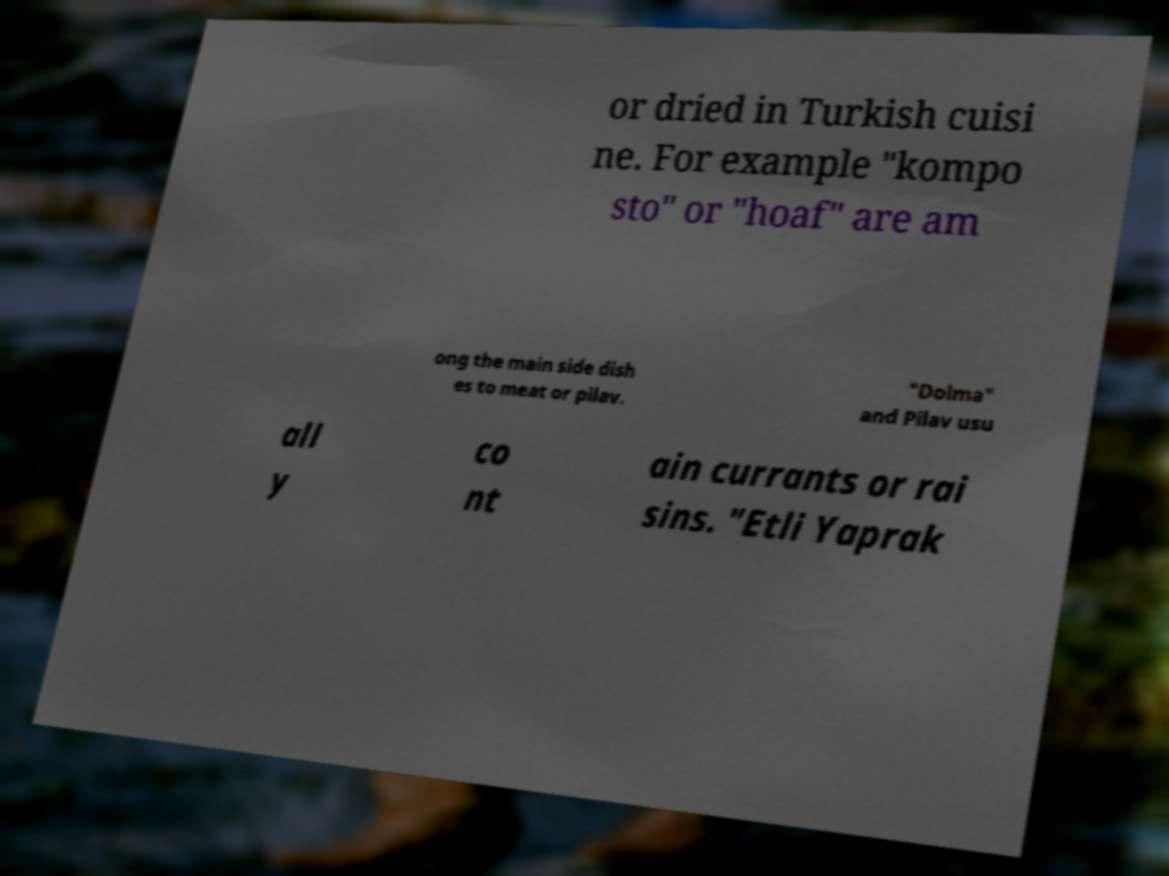Could you extract and type out the text from this image? or dried in Turkish cuisi ne. For example "kompo sto" or "hoaf" are am ong the main side dish es to meat or pilav. "Dolma" and Pilav usu all y co nt ain currants or rai sins. "Etli Yaprak 